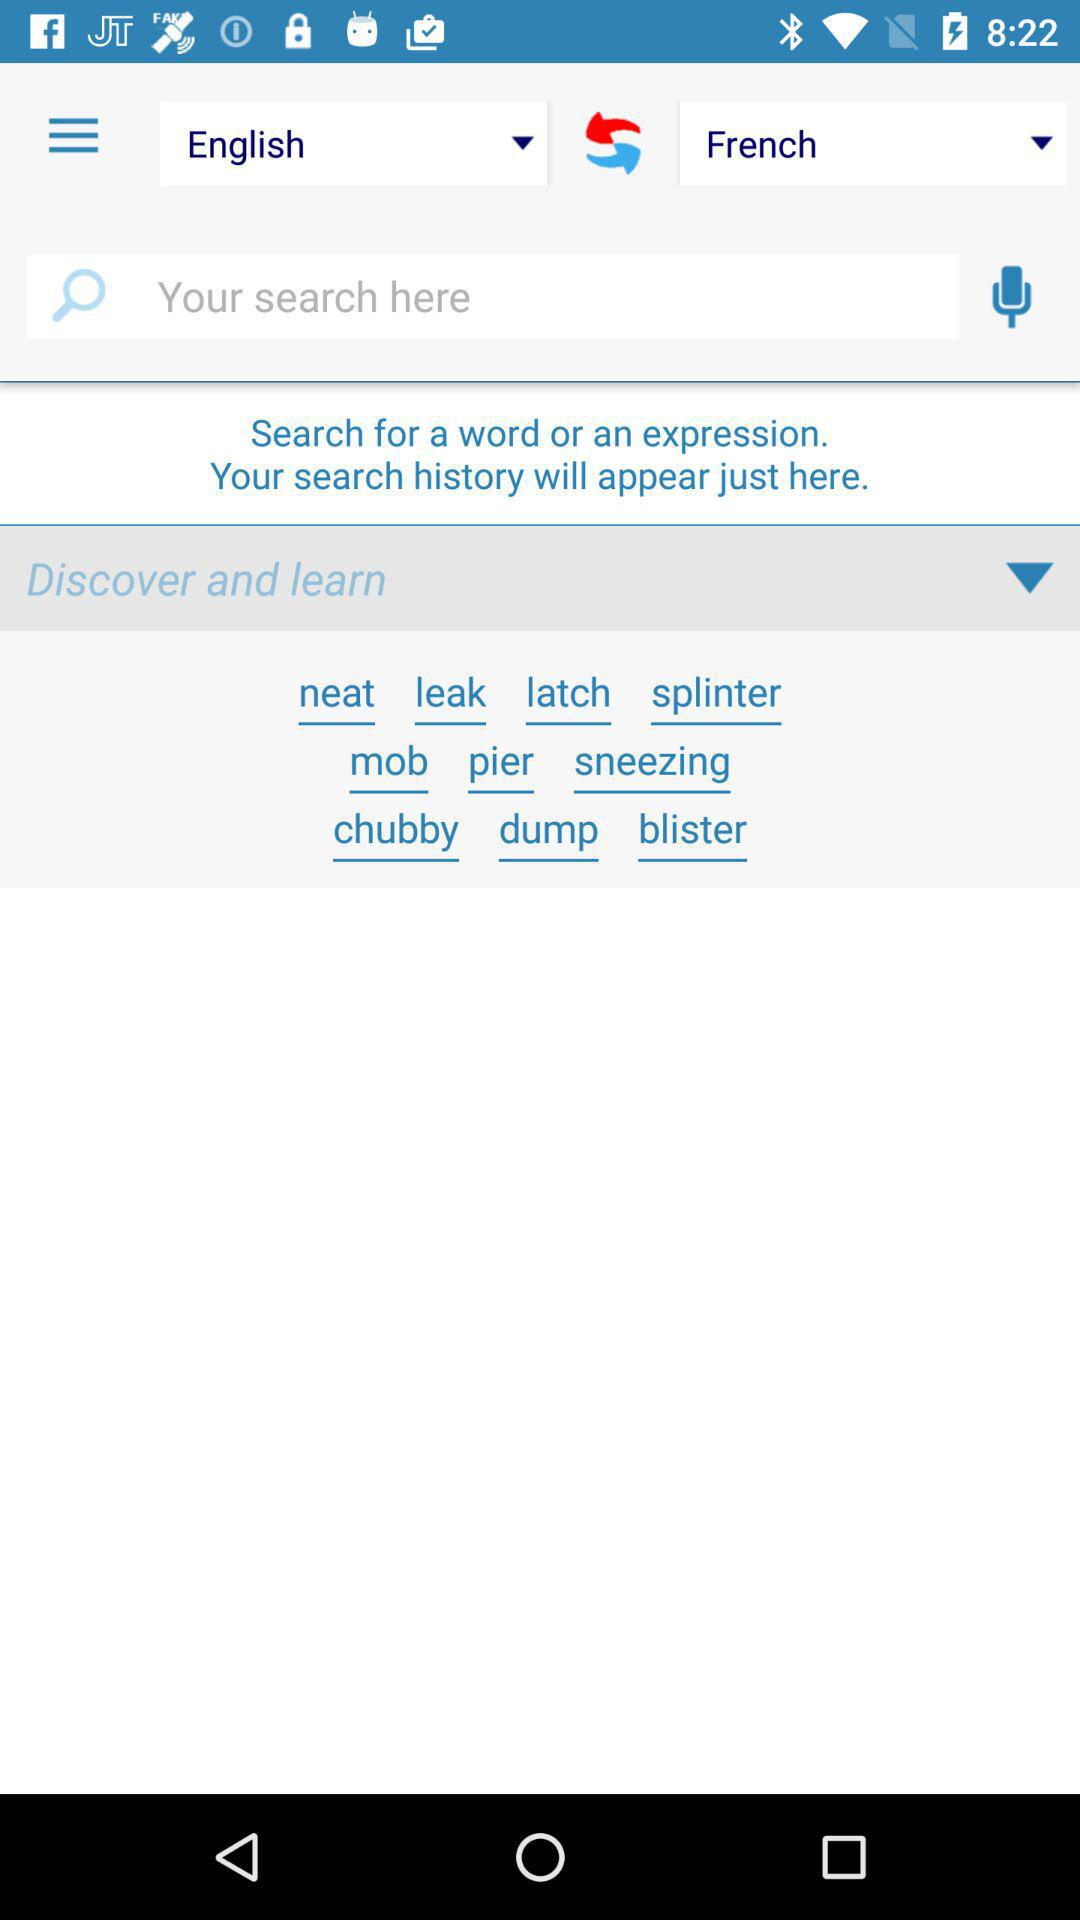How many languages are supported in this app?
Answer the question using a single word or phrase. 2 